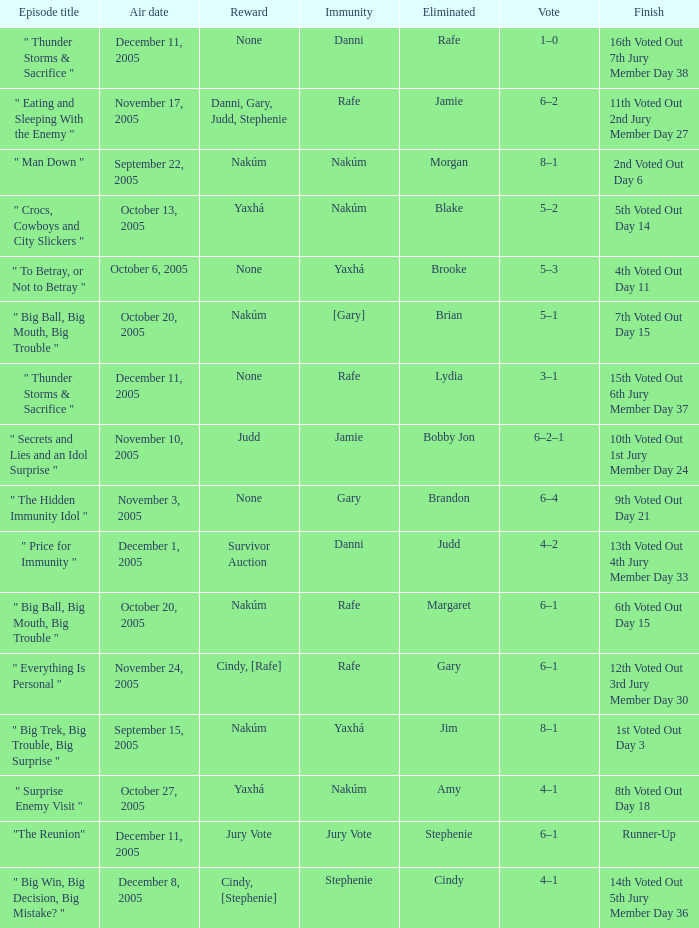Can you give me this table as a dict? {'header': ['Episode title', 'Air date', 'Reward', 'Immunity', 'Eliminated', 'Vote', 'Finish'], 'rows': [['" Thunder Storms & Sacrifice "', 'December 11, 2005', 'None', 'Danni', 'Rafe', '1–0', '16th Voted Out 7th Jury Member Day 38'], ['" Eating and Sleeping With the Enemy "', 'November 17, 2005', 'Danni, Gary, Judd, Stephenie', 'Rafe', 'Jamie', '6–2', '11th Voted Out 2nd Jury Member Day 27'], ['" Man Down "', 'September 22, 2005', 'Nakúm', 'Nakúm', 'Morgan', '8–1', '2nd Voted Out Day 6'], ['" Crocs, Cowboys and City Slickers "', 'October 13, 2005', 'Yaxhá', 'Nakúm', 'Blake', '5–2', '5th Voted Out Day 14'], ['" To Betray, or Not to Betray "', 'October 6, 2005', 'None', 'Yaxhá', 'Brooke', '5–3', '4th Voted Out Day 11'], ['" Big Ball, Big Mouth, Big Trouble "', 'October 20, 2005', 'Nakúm', '[Gary]', 'Brian', '5–1', '7th Voted Out Day 15'], ['" Thunder Storms & Sacrifice "', 'December 11, 2005', 'None', 'Rafe', 'Lydia', '3–1', '15th Voted Out 6th Jury Member Day 37'], ['" Secrets and Lies and an Idol Surprise "', 'November 10, 2005', 'Judd', 'Jamie', 'Bobby Jon', '6–2–1', '10th Voted Out 1st Jury Member Day 24'], ['" The Hidden Immunity Idol "', 'November 3, 2005', 'None', 'Gary', 'Brandon', '6–4', '9th Voted Out Day 21'], ['" Price for Immunity "', 'December 1, 2005', 'Survivor Auction', 'Danni', 'Judd', '4–2', '13th Voted Out 4th Jury Member Day 33'], ['" Big Ball, Big Mouth, Big Trouble "', 'October 20, 2005', 'Nakúm', 'Rafe', 'Margaret', '6–1', '6th Voted Out Day 15'], ['" Everything Is Personal "', 'November 24, 2005', 'Cindy, [Rafe]', 'Rafe', 'Gary', '6–1', '12th Voted Out 3rd Jury Member Day 30'], ['" Big Trek, Big Trouble, Big Surprise "', 'September 15, 2005', 'Nakúm', 'Yaxhá', 'Jim', '8–1', '1st Voted Out Day 3'], ['" Surprise Enemy Visit "', 'October 27, 2005', 'Yaxhá', 'Nakúm', 'Amy', '4–1', '8th Voted Out Day 18'], ['"The Reunion"', 'December 11, 2005', 'Jury Vote', 'Jury Vote', 'Stephenie', '6–1', 'Runner-Up'], ['" Big Win, Big Decision, Big Mistake? "', 'December 8, 2005', 'Cindy, [Stephenie]', 'Stephenie', 'Cindy', '4–1', '14th Voted Out 5th Jury Member Day 36']]} When jim is eliminated what is the finish? 1st Voted Out Day 3. 